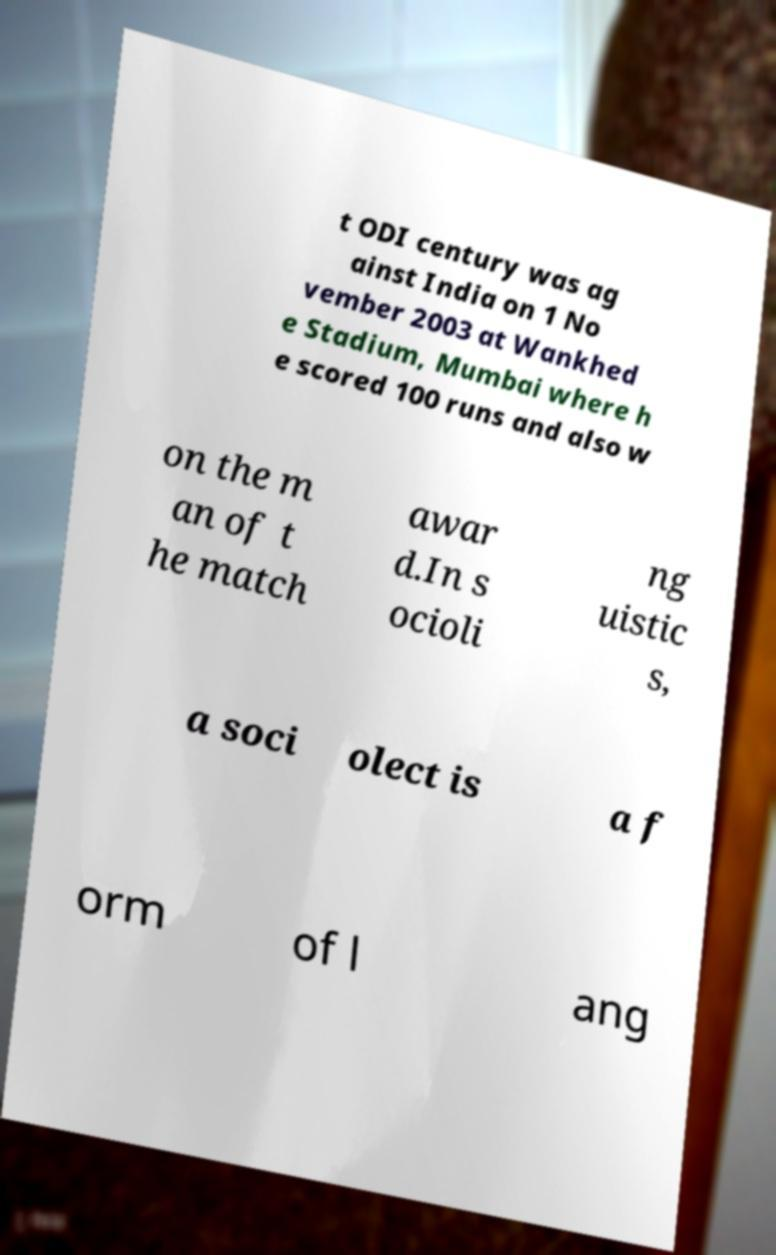Can you read and provide the text displayed in the image?This photo seems to have some interesting text. Can you extract and type it out for me? t ODI century was ag ainst India on 1 No vember 2003 at Wankhed e Stadium, Mumbai where h e scored 100 runs and also w on the m an of t he match awar d.In s ocioli ng uistic s, a soci olect is a f orm of l ang 